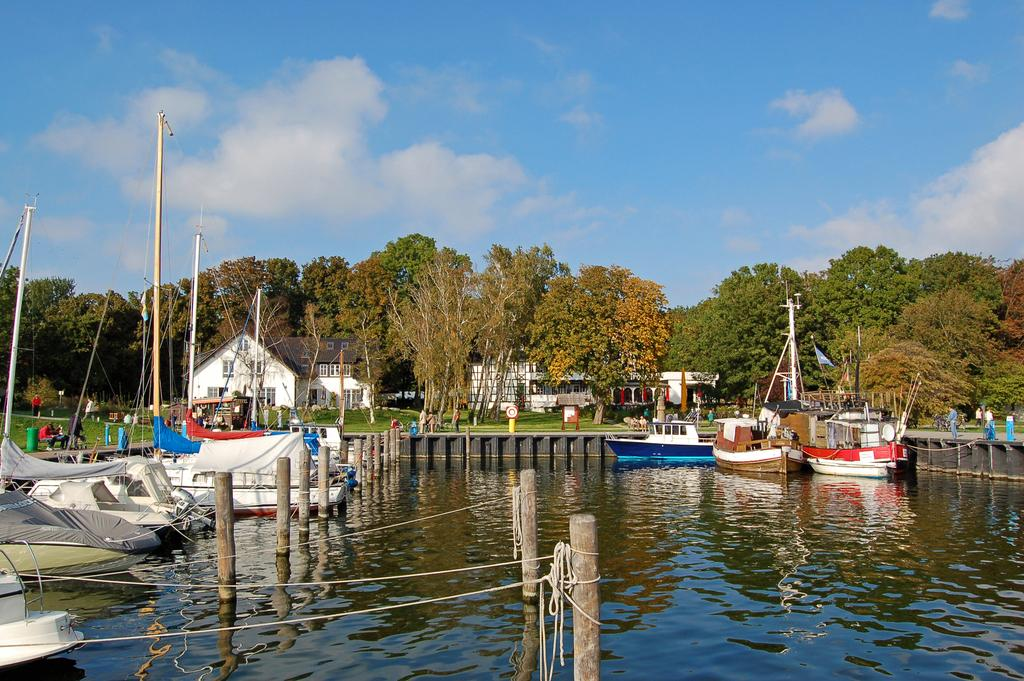What is the main subject of the image? The main subject of the image is a group of boats. Where are the boats located? The boats are on water. What can be seen in the background of the image? There are houses, trees, and the sky visible in the background of the image. What type of bears can be seen accompanying the boats in the image? There are no bears present in the image; it features a group of boats on water with a background of houses, trees, and the sky. 